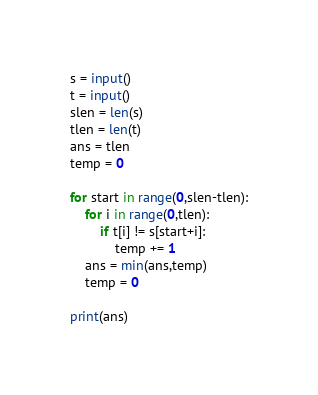Convert code to text. <code><loc_0><loc_0><loc_500><loc_500><_Python_>s = input()
t = input()
slen = len(s)
tlen = len(t)
ans = tlen
temp = 0

for start in range(0,slen-tlen):
    for i in range(0,tlen):
        if t[i] != s[start+i]:
            temp += 1
    ans = min(ans,temp)
    temp = 0

print(ans)

</code> 